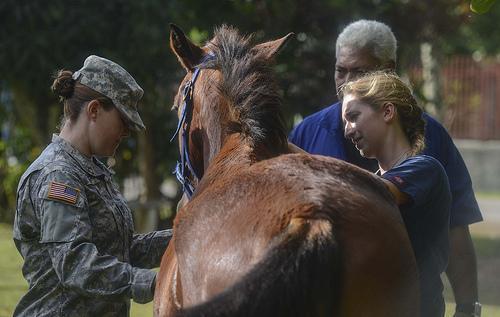How many people wearing blue?
Give a very brief answer. 2. 